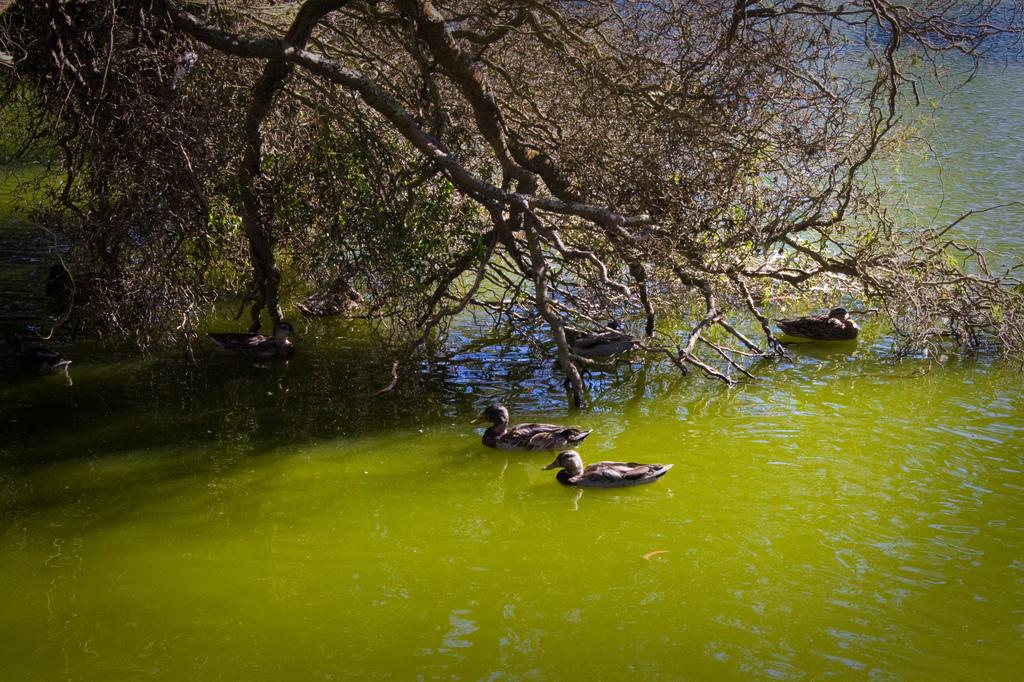What type of animals can be seen in the image? There are birds in the water in the image. What is the color of the water in the image? The water is green in color. What can be seen in the background of the image? There are many trees in the background of the image. Is the water in the image actually quicksand? No, the water in the image is not quicksand; it is green in color and has birds in it. Can you see a zephyr blowing through the trees in the background? There is no mention of a zephyr in the image, and the focus is on the birds in the water and the trees in the background. 